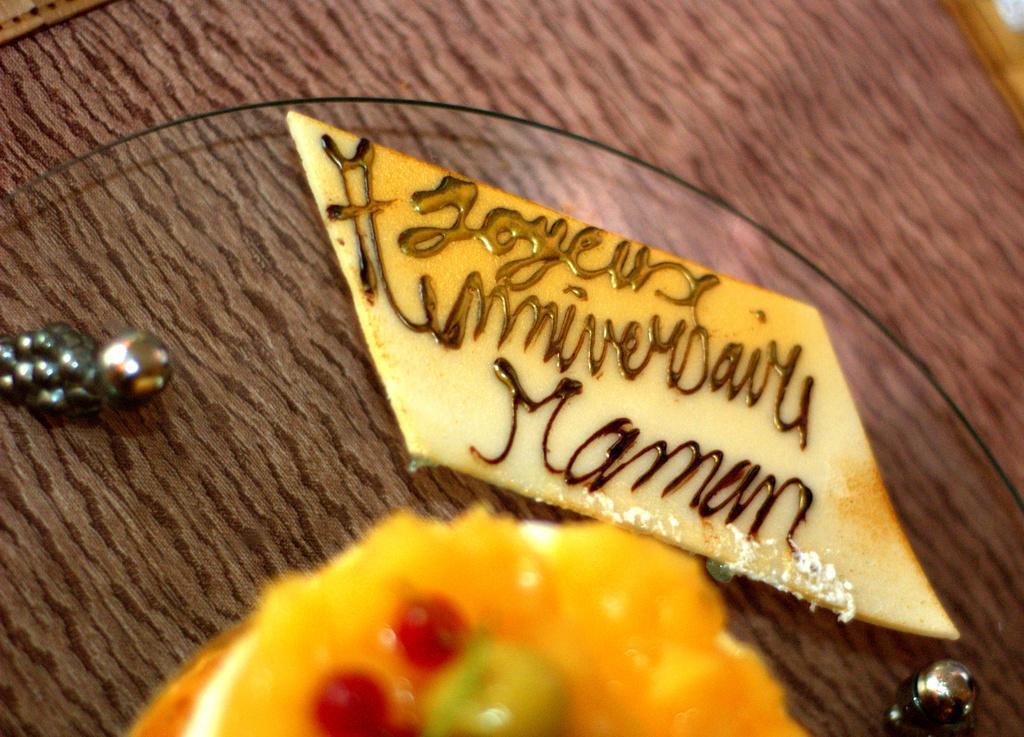In one or two sentences, can you explain what this image depicts? Here I can see a table on which a cake and some other objects are placed. Here I can see a white color object on which there is some text. 